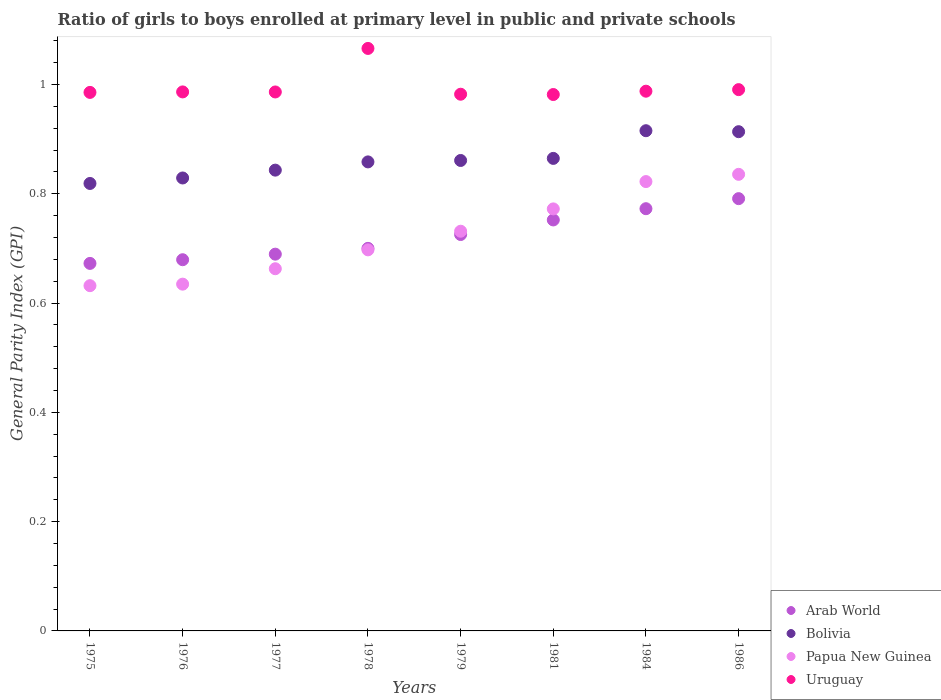What is the general parity index in Uruguay in 1979?
Offer a terse response. 0.98. Across all years, what is the maximum general parity index in Uruguay?
Make the answer very short. 1.07. Across all years, what is the minimum general parity index in Bolivia?
Give a very brief answer. 0.82. In which year was the general parity index in Uruguay minimum?
Make the answer very short. 1981. What is the total general parity index in Papua New Guinea in the graph?
Provide a succinct answer. 5.79. What is the difference between the general parity index in Papua New Guinea in 1981 and that in 1984?
Offer a very short reply. -0.05. What is the difference between the general parity index in Bolivia in 1979 and the general parity index in Uruguay in 1981?
Offer a very short reply. -0.12. What is the average general parity index in Uruguay per year?
Provide a short and direct response. 1. In the year 1981, what is the difference between the general parity index in Papua New Guinea and general parity index in Arab World?
Offer a very short reply. 0.02. In how many years, is the general parity index in Arab World greater than 0.28?
Your answer should be very brief. 8. What is the ratio of the general parity index in Papua New Guinea in 1976 to that in 1981?
Keep it short and to the point. 0.82. Is the difference between the general parity index in Papua New Guinea in 1981 and 1984 greater than the difference between the general parity index in Arab World in 1981 and 1984?
Make the answer very short. No. What is the difference between the highest and the second highest general parity index in Bolivia?
Offer a very short reply. 0. What is the difference between the highest and the lowest general parity index in Papua New Guinea?
Provide a short and direct response. 0.2. Is the sum of the general parity index in Arab World in 1977 and 1984 greater than the maximum general parity index in Uruguay across all years?
Provide a succinct answer. Yes. Is it the case that in every year, the sum of the general parity index in Papua New Guinea and general parity index in Arab World  is greater than the sum of general parity index in Bolivia and general parity index in Uruguay?
Offer a terse response. No. Is it the case that in every year, the sum of the general parity index in Papua New Guinea and general parity index in Arab World  is greater than the general parity index in Bolivia?
Provide a succinct answer. Yes. Does the general parity index in Uruguay monotonically increase over the years?
Offer a very short reply. No. Is the general parity index in Bolivia strictly greater than the general parity index in Papua New Guinea over the years?
Your answer should be very brief. Yes. Is the general parity index in Uruguay strictly less than the general parity index in Bolivia over the years?
Give a very brief answer. No. Are the values on the major ticks of Y-axis written in scientific E-notation?
Offer a terse response. No. Does the graph contain any zero values?
Your answer should be compact. No. Where does the legend appear in the graph?
Your response must be concise. Bottom right. How many legend labels are there?
Provide a short and direct response. 4. How are the legend labels stacked?
Your answer should be very brief. Vertical. What is the title of the graph?
Offer a terse response. Ratio of girls to boys enrolled at primary level in public and private schools. Does "High income: OECD" appear as one of the legend labels in the graph?
Your answer should be very brief. No. What is the label or title of the X-axis?
Your answer should be very brief. Years. What is the label or title of the Y-axis?
Ensure brevity in your answer.  General Parity Index (GPI). What is the General Parity Index (GPI) of Arab World in 1975?
Your answer should be compact. 0.67. What is the General Parity Index (GPI) in Bolivia in 1975?
Ensure brevity in your answer.  0.82. What is the General Parity Index (GPI) of Papua New Guinea in 1975?
Your answer should be very brief. 0.63. What is the General Parity Index (GPI) of Uruguay in 1975?
Keep it short and to the point. 0.99. What is the General Parity Index (GPI) of Arab World in 1976?
Ensure brevity in your answer.  0.68. What is the General Parity Index (GPI) of Bolivia in 1976?
Provide a succinct answer. 0.83. What is the General Parity Index (GPI) in Papua New Guinea in 1976?
Keep it short and to the point. 0.63. What is the General Parity Index (GPI) of Uruguay in 1976?
Give a very brief answer. 0.99. What is the General Parity Index (GPI) in Arab World in 1977?
Give a very brief answer. 0.69. What is the General Parity Index (GPI) in Bolivia in 1977?
Keep it short and to the point. 0.84. What is the General Parity Index (GPI) in Papua New Guinea in 1977?
Offer a very short reply. 0.66. What is the General Parity Index (GPI) in Uruguay in 1977?
Provide a short and direct response. 0.99. What is the General Parity Index (GPI) in Arab World in 1978?
Your answer should be compact. 0.7. What is the General Parity Index (GPI) in Bolivia in 1978?
Your answer should be compact. 0.86. What is the General Parity Index (GPI) of Papua New Guinea in 1978?
Make the answer very short. 0.7. What is the General Parity Index (GPI) of Uruguay in 1978?
Your response must be concise. 1.07. What is the General Parity Index (GPI) in Arab World in 1979?
Your answer should be compact. 0.73. What is the General Parity Index (GPI) in Bolivia in 1979?
Give a very brief answer. 0.86. What is the General Parity Index (GPI) in Papua New Guinea in 1979?
Keep it short and to the point. 0.73. What is the General Parity Index (GPI) in Uruguay in 1979?
Make the answer very short. 0.98. What is the General Parity Index (GPI) of Arab World in 1981?
Provide a short and direct response. 0.75. What is the General Parity Index (GPI) in Bolivia in 1981?
Ensure brevity in your answer.  0.86. What is the General Parity Index (GPI) in Papua New Guinea in 1981?
Your answer should be very brief. 0.77. What is the General Parity Index (GPI) of Uruguay in 1981?
Make the answer very short. 0.98. What is the General Parity Index (GPI) of Arab World in 1984?
Make the answer very short. 0.77. What is the General Parity Index (GPI) of Bolivia in 1984?
Provide a succinct answer. 0.92. What is the General Parity Index (GPI) of Papua New Guinea in 1984?
Make the answer very short. 0.82. What is the General Parity Index (GPI) in Uruguay in 1984?
Your answer should be very brief. 0.99. What is the General Parity Index (GPI) of Arab World in 1986?
Keep it short and to the point. 0.79. What is the General Parity Index (GPI) in Bolivia in 1986?
Make the answer very short. 0.91. What is the General Parity Index (GPI) of Papua New Guinea in 1986?
Make the answer very short. 0.84. What is the General Parity Index (GPI) in Uruguay in 1986?
Make the answer very short. 0.99. Across all years, what is the maximum General Parity Index (GPI) in Arab World?
Ensure brevity in your answer.  0.79. Across all years, what is the maximum General Parity Index (GPI) of Bolivia?
Your response must be concise. 0.92. Across all years, what is the maximum General Parity Index (GPI) of Papua New Guinea?
Provide a short and direct response. 0.84. Across all years, what is the maximum General Parity Index (GPI) of Uruguay?
Offer a terse response. 1.07. Across all years, what is the minimum General Parity Index (GPI) in Arab World?
Keep it short and to the point. 0.67. Across all years, what is the minimum General Parity Index (GPI) in Bolivia?
Provide a succinct answer. 0.82. Across all years, what is the minimum General Parity Index (GPI) of Papua New Guinea?
Make the answer very short. 0.63. Across all years, what is the minimum General Parity Index (GPI) in Uruguay?
Your answer should be very brief. 0.98. What is the total General Parity Index (GPI) in Arab World in the graph?
Make the answer very short. 5.78. What is the total General Parity Index (GPI) in Bolivia in the graph?
Your answer should be very brief. 6.9. What is the total General Parity Index (GPI) of Papua New Guinea in the graph?
Provide a short and direct response. 5.79. What is the total General Parity Index (GPI) in Uruguay in the graph?
Provide a short and direct response. 7.97. What is the difference between the General Parity Index (GPI) of Arab World in 1975 and that in 1976?
Your answer should be compact. -0.01. What is the difference between the General Parity Index (GPI) in Bolivia in 1975 and that in 1976?
Ensure brevity in your answer.  -0.01. What is the difference between the General Parity Index (GPI) in Papua New Guinea in 1975 and that in 1976?
Provide a short and direct response. -0. What is the difference between the General Parity Index (GPI) of Uruguay in 1975 and that in 1976?
Keep it short and to the point. -0. What is the difference between the General Parity Index (GPI) of Arab World in 1975 and that in 1977?
Provide a succinct answer. -0.02. What is the difference between the General Parity Index (GPI) in Bolivia in 1975 and that in 1977?
Your answer should be very brief. -0.02. What is the difference between the General Parity Index (GPI) of Papua New Guinea in 1975 and that in 1977?
Your answer should be very brief. -0.03. What is the difference between the General Parity Index (GPI) in Uruguay in 1975 and that in 1977?
Ensure brevity in your answer.  -0. What is the difference between the General Parity Index (GPI) in Arab World in 1975 and that in 1978?
Give a very brief answer. -0.03. What is the difference between the General Parity Index (GPI) of Bolivia in 1975 and that in 1978?
Your response must be concise. -0.04. What is the difference between the General Parity Index (GPI) in Papua New Guinea in 1975 and that in 1978?
Offer a terse response. -0.07. What is the difference between the General Parity Index (GPI) in Uruguay in 1975 and that in 1978?
Give a very brief answer. -0.08. What is the difference between the General Parity Index (GPI) in Arab World in 1975 and that in 1979?
Offer a terse response. -0.05. What is the difference between the General Parity Index (GPI) in Bolivia in 1975 and that in 1979?
Your response must be concise. -0.04. What is the difference between the General Parity Index (GPI) in Papua New Guinea in 1975 and that in 1979?
Provide a short and direct response. -0.1. What is the difference between the General Parity Index (GPI) in Uruguay in 1975 and that in 1979?
Give a very brief answer. 0. What is the difference between the General Parity Index (GPI) of Arab World in 1975 and that in 1981?
Your response must be concise. -0.08. What is the difference between the General Parity Index (GPI) of Bolivia in 1975 and that in 1981?
Your answer should be compact. -0.05. What is the difference between the General Parity Index (GPI) in Papua New Guinea in 1975 and that in 1981?
Give a very brief answer. -0.14. What is the difference between the General Parity Index (GPI) in Uruguay in 1975 and that in 1981?
Your answer should be compact. 0. What is the difference between the General Parity Index (GPI) of Arab World in 1975 and that in 1984?
Offer a terse response. -0.1. What is the difference between the General Parity Index (GPI) of Bolivia in 1975 and that in 1984?
Ensure brevity in your answer.  -0.1. What is the difference between the General Parity Index (GPI) of Papua New Guinea in 1975 and that in 1984?
Provide a short and direct response. -0.19. What is the difference between the General Parity Index (GPI) in Uruguay in 1975 and that in 1984?
Your answer should be very brief. -0. What is the difference between the General Parity Index (GPI) in Arab World in 1975 and that in 1986?
Your response must be concise. -0.12. What is the difference between the General Parity Index (GPI) in Bolivia in 1975 and that in 1986?
Provide a succinct answer. -0.09. What is the difference between the General Parity Index (GPI) of Papua New Guinea in 1975 and that in 1986?
Keep it short and to the point. -0.2. What is the difference between the General Parity Index (GPI) in Uruguay in 1975 and that in 1986?
Provide a short and direct response. -0.01. What is the difference between the General Parity Index (GPI) of Arab World in 1976 and that in 1977?
Offer a very short reply. -0.01. What is the difference between the General Parity Index (GPI) of Bolivia in 1976 and that in 1977?
Provide a succinct answer. -0.01. What is the difference between the General Parity Index (GPI) in Papua New Guinea in 1976 and that in 1977?
Make the answer very short. -0.03. What is the difference between the General Parity Index (GPI) in Arab World in 1976 and that in 1978?
Provide a succinct answer. -0.02. What is the difference between the General Parity Index (GPI) of Bolivia in 1976 and that in 1978?
Make the answer very short. -0.03. What is the difference between the General Parity Index (GPI) of Papua New Guinea in 1976 and that in 1978?
Your answer should be compact. -0.06. What is the difference between the General Parity Index (GPI) of Uruguay in 1976 and that in 1978?
Ensure brevity in your answer.  -0.08. What is the difference between the General Parity Index (GPI) of Arab World in 1976 and that in 1979?
Provide a succinct answer. -0.05. What is the difference between the General Parity Index (GPI) in Bolivia in 1976 and that in 1979?
Provide a short and direct response. -0.03. What is the difference between the General Parity Index (GPI) in Papua New Guinea in 1976 and that in 1979?
Your answer should be compact. -0.1. What is the difference between the General Parity Index (GPI) in Uruguay in 1976 and that in 1979?
Your answer should be very brief. 0. What is the difference between the General Parity Index (GPI) in Arab World in 1976 and that in 1981?
Provide a short and direct response. -0.07. What is the difference between the General Parity Index (GPI) in Bolivia in 1976 and that in 1981?
Make the answer very short. -0.04. What is the difference between the General Parity Index (GPI) of Papua New Guinea in 1976 and that in 1981?
Give a very brief answer. -0.14. What is the difference between the General Parity Index (GPI) of Uruguay in 1976 and that in 1981?
Make the answer very short. 0. What is the difference between the General Parity Index (GPI) of Arab World in 1976 and that in 1984?
Ensure brevity in your answer.  -0.09. What is the difference between the General Parity Index (GPI) of Bolivia in 1976 and that in 1984?
Ensure brevity in your answer.  -0.09. What is the difference between the General Parity Index (GPI) in Papua New Guinea in 1976 and that in 1984?
Make the answer very short. -0.19. What is the difference between the General Parity Index (GPI) of Uruguay in 1976 and that in 1984?
Provide a succinct answer. -0. What is the difference between the General Parity Index (GPI) in Arab World in 1976 and that in 1986?
Provide a short and direct response. -0.11. What is the difference between the General Parity Index (GPI) in Bolivia in 1976 and that in 1986?
Provide a short and direct response. -0.08. What is the difference between the General Parity Index (GPI) in Papua New Guinea in 1976 and that in 1986?
Ensure brevity in your answer.  -0.2. What is the difference between the General Parity Index (GPI) of Uruguay in 1976 and that in 1986?
Provide a short and direct response. -0. What is the difference between the General Parity Index (GPI) of Arab World in 1977 and that in 1978?
Your answer should be very brief. -0.01. What is the difference between the General Parity Index (GPI) of Bolivia in 1977 and that in 1978?
Make the answer very short. -0.02. What is the difference between the General Parity Index (GPI) of Papua New Guinea in 1977 and that in 1978?
Offer a very short reply. -0.03. What is the difference between the General Parity Index (GPI) of Uruguay in 1977 and that in 1978?
Your response must be concise. -0.08. What is the difference between the General Parity Index (GPI) of Arab World in 1977 and that in 1979?
Your response must be concise. -0.04. What is the difference between the General Parity Index (GPI) in Bolivia in 1977 and that in 1979?
Ensure brevity in your answer.  -0.02. What is the difference between the General Parity Index (GPI) of Papua New Guinea in 1977 and that in 1979?
Offer a terse response. -0.07. What is the difference between the General Parity Index (GPI) of Uruguay in 1977 and that in 1979?
Provide a succinct answer. 0. What is the difference between the General Parity Index (GPI) of Arab World in 1977 and that in 1981?
Ensure brevity in your answer.  -0.06. What is the difference between the General Parity Index (GPI) of Bolivia in 1977 and that in 1981?
Make the answer very short. -0.02. What is the difference between the General Parity Index (GPI) of Papua New Guinea in 1977 and that in 1981?
Make the answer very short. -0.11. What is the difference between the General Parity Index (GPI) of Uruguay in 1977 and that in 1981?
Give a very brief answer. 0. What is the difference between the General Parity Index (GPI) in Arab World in 1977 and that in 1984?
Ensure brevity in your answer.  -0.08. What is the difference between the General Parity Index (GPI) in Bolivia in 1977 and that in 1984?
Give a very brief answer. -0.07. What is the difference between the General Parity Index (GPI) of Papua New Guinea in 1977 and that in 1984?
Your answer should be very brief. -0.16. What is the difference between the General Parity Index (GPI) of Uruguay in 1977 and that in 1984?
Provide a succinct answer. -0. What is the difference between the General Parity Index (GPI) in Arab World in 1977 and that in 1986?
Keep it short and to the point. -0.1. What is the difference between the General Parity Index (GPI) of Bolivia in 1977 and that in 1986?
Your response must be concise. -0.07. What is the difference between the General Parity Index (GPI) of Papua New Guinea in 1977 and that in 1986?
Provide a succinct answer. -0.17. What is the difference between the General Parity Index (GPI) in Uruguay in 1977 and that in 1986?
Make the answer very short. -0. What is the difference between the General Parity Index (GPI) in Arab World in 1978 and that in 1979?
Your response must be concise. -0.03. What is the difference between the General Parity Index (GPI) in Bolivia in 1978 and that in 1979?
Keep it short and to the point. -0. What is the difference between the General Parity Index (GPI) of Papua New Guinea in 1978 and that in 1979?
Your response must be concise. -0.03. What is the difference between the General Parity Index (GPI) in Uruguay in 1978 and that in 1979?
Your answer should be very brief. 0.08. What is the difference between the General Parity Index (GPI) in Arab World in 1978 and that in 1981?
Offer a very short reply. -0.05. What is the difference between the General Parity Index (GPI) in Bolivia in 1978 and that in 1981?
Offer a terse response. -0.01. What is the difference between the General Parity Index (GPI) of Papua New Guinea in 1978 and that in 1981?
Offer a very short reply. -0.07. What is the difference between the General Parity Index (GPI) of Uruguay in 1978 and that in 1981?
Your answer should be compact. 0.08. What is the difference between the General Parity Index (GPI) in Arab World in 1978 and that in 1984?
Ensure brevity in your answer.  -0.07. What is the difference between the General Parity Index (GPI) of Bolivia in 1978 and that in 1984?
Make the answer very short. -0.06. What is the difference between the General Parity Index (GPI) of Papua New Guinea in 1978 and that in 1984?
Your answer should be very brief. -0.12. What is the difference between the General Parity Index (GPI) of Uruguay in 1978 and that in 1984?
Ensure brevity in your answer.  0.08. What is the difference between the General Parity Index (GPI) in Arab World in 1978 and that in 1986?
Offer a terse response. -0.09. What is the difference between the General Parity Index (GPI) in Bolivia in 1978 and that in 1986?
Ensure brevity in your answer.  -0.06. What is the difference between the General Parity Index (GPI) in Papua New Guinea in 1978 and that in 1986?
Make the answer very short. -0.14. What is the difference between the General Parity Index (GPI) in Uruguay in 1978 and that in 1986?
Offer a terse response. 0.08. What is the difference between the General Parity Index (GPI) in Arab World in 1979 and that in 1981?
Your answer should be compact. -0.03. What is the difference between the General Parity Index (GPI) of Bolivia in 1979 and that in 1981?
Your response must be concise. -0. What is the difference between the General Parity Index (GPI) of Papua New Guinea in 1979 and that in 1981?
Your answer should be compact. -0.04. What is the difference between the General Parity Index (GPI) of Uruguay in 1979 and that in 1981?
Offer a very short reply. 0. What is the difference between the General Parity Index (GPI) of Arab World in 1979 and that in 1984?
Your answer should be compact. -0.05. What is the difference between the General Parity Index (GPI) of Bolivia in 1979 and that in 1984?
Your response must be concise. -0.05. What is the difference between the General Parity Index (GPI) of Papua New Guinea in 1979 and that in 1984?
Keep it short and to the point. -0.09. What is the difference between the General Parity Index (GPI) in Uruguay in 1979 and that in 1984?
Keep it short and to the point. -0.01. What is the difference between the General Parity Index (GPI) in Arab World in 1979 and that in 1986?
Your answer should be very brief. -0.07. What is the difference between the General Parity Index (GPI) of Bolivia in 1979 and that in 1986?
Give a very brief answer. -0.05. What is the difference between the General Parity Index (GPI) in Papua New Guinea in 1979 and that in 1986?
Offer a very short reply. -0.1. What is the difference between the General Parity Index (GPI) of Uruguay in 1979 and that in 1986?
Your answer should be compact. -0.01. What is the difference between the General Parity Index (GPI) of Arab World in 1981 and that in 1984?
Offer a terse response. -0.02. What is the difference between the General Parity Index (GPI) in Bolivia in 1981 and that in 1984?
Your response must be concise. -0.05. What is the difference between the General Parity Index (GPI) of Papua New Guinea in 1981 and that in 1984?
Ensure brevity in your answer.  -0.05. What is the difference between the General Parity Index (GPI) in Uruguay in 1981 and that in 1984?
Offer a very short reply. -0.01. What is the difference between the General Parity Index (GPI) in Arab World in 1981 and that in 1986?
Offer a terse response. -0.04. What is the difference between the General Parity Index (GPI) of Bolivia in 1981 and that in 1986?
Your response must be concise. -0.05. What is the difference between the General Parity Index (GPI) of Papua New Guinea in 1981 and that in 1986?
Your answer should be very brief. -0.06. What is the difference between the General Parity Index (GPI) of Uruguay in 1981 and that in 1986?
Keep it short and to the point. -0.01. What is the difference between the General Parity Index (GPI) in Arab World in 1984 and that in 1986?
Your answer should be very brief. -0.02. What is the difference between the General Parity Index (GPI) in Bolivia in 1984 and that in 1986?
Keep it short and to the point. 0. What is the difference between the General Parity Index (GPI) of Papua New Guinea in 1984 and that in 1986?
Give a very brief answer. -0.01. What is the difference between the General Parity Index (GPI) of Uruguay in 1984 and that in 1986?
Provide a succinct answer. -0. What is the difference between the General Parity Index (GPI) in Arab World in 1975 and the General Parity Index (GPI) in Bolivia in 1976?
Your response must be concise. -0.16. What is the difference between the General Parity Index (GPI) of Arab World in 1975 and the General Parity Index (GPI) of Papua New Guinea in 1976?
Give a very brief answer. 0.04. What is the difference between the General Parity Index (GPI) of Arab World in 1975 and the General Parity Index (GPI) of Uruguay in 1976?
Ensure brevity in your answer.  -0.31. What is the difference between the General Parity Index (GPI) of Bolivia in 1975 and the General Parity Index (GPI) of Papua New Guinea in 1976?
Provide a succinct answer. 0.18. What is the difference between the General Parity Index (GPI) in Bolivia in 1975 and the General Parity Index (GPI) in Uruguay in 1976?
Provide a succinct answer. -0.17. What is the difference between the General Parity Index (GPI) of Papua New Guinea in 1975 and the General Parity Index (GPI) of Uruguay in 1976?
Make the answer very short. -0.35. What is the difference between the General Parity Index (GPI) of Arab World in 1975 and the General Parity Index (GPI) of Bolivia in 1977?
Your answer should be very brief. -0.17. What is the difference between the General Parity Index (GPI) in Arab World in 1975 and the General Parity Index (GPI) in Papua New Guinea in 1977?
Provide a short and direct response. 0.01. What is the difference between the General Parity Index (GPI) in Arab World in 1975 and the General Parity Index (GPI) in Uruguay in 1977?
Make the answer very short. -0.31. What is the difference between the General Parity Index (GPI) in Bolivia in 1975 and the General Parity Index (GPI) in Papua New Guinea in 1977?
Keep it short and to the point. 0.16. What is the difference between the General Parity Index (GPI) in Bolivia in 1975 and the General Parity Index (GPI) in Uruguay in 1977?
Offer a terse response. -0.17. What is the difference between the General Parity Index (GPI) in Papua New Guinea in 1975 and the General Parity Index (GPI) in Uruguay in 1977?
Offer a very short reply. -0.35. What is the difference between the General Parity Index (GPI) of Arab World in 1975 and the General Parity Index (GPI) of Bolivia in 1978?
Offer a very short reply. -0.19. What is the difference between the General Parity Index (GPI) of Arab World in 1975 and the General Parity Index (GPI) of Papua New Guinea in 1978?
Your response must be concise. -0.02. What is the difference between the General Parity Index (GPI) of Arab World in 1975 and the General Parity Index (GPI) of Uruguay in 1978?
Ensure brevity in your answer.  -0.39. What is the difference between the General Parity Index (GPI) of Bolivia in 1975 and the General Parity Index (GPI) of Papua New Guinea in 1978?
Offer a terse response. 0.12. What is the difference between the General Parity Index (GPI) of Bolivia in 1975 and the General Parity Index (GPI) of Uruguay in 1978?
Provide a short and direct response. -0.25. What is the difference between the General Parity Index (GPI) in Papua New Guinea in 1975 and the General Parity Index (GPI) in Uruguay in 1978?
Make the answer very short. -0.43. What is the difference between the General Parity Index (GPI) of Arab World in 1975 and the General Parity Index (GPI) of Bolivia in 1979?
Ensure brevity in your answer.  -0.19. What is the difference between the General Parity Index (GPI) in Arab World in 1975 and the General Parity Index (GPI) in Papua New Guinea in 1979?
Your answer should be compact. -0.06. What is the difference between the General Parity Index (GPI) of Arab World in 1975 and the General Parity Index (GPI) of Uruguay in 1979?
Offer a terse response. -0.31. What is the difference between the General Parity Index (GPI) in Bolivia in 1975 and the General Parity Index (GPI) in Papua New Guinea in 1979?
Provide a short and direct response. 0.09. What is the difference between the General Parity Index (GPI) in Bolivia in 1975 and the General Parity Index (GPI) in Uruguay in 1979?
Ensure brevity in your answer.  -0.16. What is the difference between the General Parity Index (GPI) in Papua New Guinea in 1975 and the General Parity Index (GPI) in Uruguay in 1979?
Ensure brevity in your answer.  -0.35. What is the difference between the General Parity Index (GPI) of Arab World in 1975 and the General Parity Index (GPI) of Bolivia in 1981?
Your response must be concise. -0.19. What is the difference between the General Parity Index (GPI) of Arab World in 1975 and the General Parity Index (GPI) of Papua New Guinea in 1981?
Offer a terse response. -0.1. What is the difference between the General Parity Index (GPI) of Arab World in 1975 and the General Parity Index (GPI) of Uruguay in 1981?
Your response must be concise. -0.31. What is the difference between the General Parity Index (GPI) of Bolivia in 1975 and the General Parity Index (GPI) of Papua New Guinea in 1981?
Your answer should be very brief. 0.05. What is the difference between the General Parity Index (GPI) of Bolivia in 1975 and the General Parity Index (GPI) of Uruguay in 1981?
Your answer should be very brief. -0.16. What is the difference between the General Parity Index (GPI) in Papua New Guinea in 1975 and the General Parity Index (GPI) in Uruguay in 1981?
Your answer should be compact. -0.35. What is the difference between the General Parity Index (GPI) of Arab World in 1975 and the General Parity Index (GPI) of Bolivia in 1984?
Offer a terse response. -0.24. What is the difference between the General Parity Index (GPI) in Arab World in 1975 and the General Parity Index (GPI) in Papua New Guinea in 1984?
Ensure brevity in your answer.  -0.15. What is the difference between the General Parity Index (GPI) of Arab World in 1975 and the General Parity Index (GPI) of Uruguay in 1984?
Your answer should be very brief. -0.32. What is the difference between the General Parity Index (GPI) of Bolivia in 1975 and the General Parity Index (GPI) of Papua New Guinea in 1984?
Your answer should be compact. -0. What is the difference between the General Parity Index (GPI) in Bolivia in 1975 and the General Parity Index (GPI) in Uruguay in 1984?
Provide a succinct answer. -0.17. What is the difference between the General Parity Index (GPI) in Papua New Guinea in 1975 and the General Parity Index (GPI) in Uruguay in 1984?
Your answer should be very brief. -0.36. What is the difference between the General Parity Index (GPI) of Arab World in 1975 and the General Parity Index (GPI) of Bolivia in 1986?
Keep it short and to the point. -0.24. What is the difference between the General Parity Index (GPI) of Arab World in 1975 and the General Parity Index (GPI) of Papua New Guinea in 1986?
Make the answer very short. -0.16. What is the difference between the General Parity Index (GPI) in Arab World in 1975 and the General Parity Index (GPI) in Uruguay in 1986?
Ensure brevity in your answer.  -0.32. What is the difference between the General Parity Index (GPI) in Bolivia in 1975 and the General Parity Index (GPI) in Papua New Guinea in 1986?
Offer a very short reply. -0.02. What is the difference between the General Parity Index (GPI) of Bolivia in 1975 and the General Parity Index (GPI) of Uruguay in 1986?
Provide a short and direct response. -0.17. What is the difference between the General Parity Index (GPI) of Papua New Guinea in 1975 and the General Parity Index (GPI) of Uruguay in 1986?
Make the answer very short. -0.36. What is the difference between the General Parity Index (GPI) of Arab World in 1976 and the General Parity Index (GPI) of Bolivia in 1977?
Your response must be concise. -0.16. What is the difference between the General Parity Index (GPI) of Arab World in 1976 and the General Parity Index (GPI) of Papua New Guinea in 1977?
Provide a short and direct response. 0.02. What is the difference between the General Parity Index (GPI) of Arab World in 1976 and the General Parity Index (GPI) of Uruguay in 1977?
Your answer should be very brief. -0.31. What is the difference between the General Parity Index (GPI) of Bolivia in 1976 and the General Parity Index (GPI) of Papua New Guinea in 1977?
Make the answer very short. 0.17. What is the difference between the General Parity Index (GPI) in Bolivia in 1976 and the General Parity Index (GPI) in Uruguay in 1977?
Keep it short and to the point. -0.16. What is the difference between the General Parity Index (GPI) in Papua New Guinea in 1976 and the General Parity Index (GPI) in Uruguay in 1977?
Offer a terse response. -0.35. What is the difference between the General Parity Index (GPI) of Arab World in 1976 and the General Parity Index (GPI) of Bolivia in 1978?
Ensure brevity in your answer.  -0.18. What is the difference between the General Parity Index (GPI) in Arab World in 1976 and the General Parity Index (GPI) in Papua New Guinea in 1978?
Ensure brevity in your answer.  -0.02. What is the difference between the General Parity Index (GPI) in Arab World in 1976 and the General Parity Index (GPI) in Uruguay in 1978?
Give a very brief answer. -0.39. What is the difference between the General Parity Index (GPI) of Bolivia in 1976 and the General Parity Index (GPI) of Papua New Guinea in 1978?
Your answer should be very brief. 0.13. What is the difference between the General Parity Index (GPI) of Bolivia in 1976 and the General Parity Index (GPI) of Uruguay in 1978?
Keep it short and to the point. -0.24. What is the difference between the General Parity Index (GPI) of Papua New Guinea in 1976 and the General Parity Index (GPI) of Uruguay in 1978?
Keep it short and to the point. -0.43. What is the difference between the General Parity Index (GPI) in Arab World in 1976 and the General Parity Index (GPI) in Bolivia in 1979?
Offer a terse response. -0.18. What is the difference between the General Parity Index (GPI) in Arab World in 1976 and the General Parity Index (GPI) in Papua New Guinea in 1979?
Offer a terse response. -0.05. What is the difference between the General Parity Index (GPI) of Arab World in 1976 and the General Parity Index (GPI) of Uruguay in 1979?
Provide a short and direct response. -0.3. What is the difference between the General Parity Index (GPI) in Bolivia in 1976 and the General Parity Index (GPI) in Papua New Guinea in 1979?
Keep it short and to the point. 0.1. What is the difference between the General Parity Index (GPI) in Bolivia in 1976 and the General Parity Index (GPI) in Uruguay in 1979?
Keep it short and to the point. -0.15. What is the difference between the General Parity Index (GPI) in Papua New Guinea in 1976 and the General Parity Index (GPI) in Uruguay in 1979?
Provide a succinct answer. -0.35. What is the difference between the General Parity Index (GPI) in Arab World in 1976 and the General Parity Index (GPI) in Bolivia in 1981?
Provide a succinct answer. -0.19. What is the difference between the General Parity Index (GPI) in Arab World in 1976 and the General Parity Index (GPI) in Papua New Guinea in 1981?
Ensure brevity in your answer.  -0.09. What is the difference between the General Parity Index (GPI) of Arab World in 1976 and the General Parity Index (GPI) of Uruguay in 1981?
Keep it short and to the point. -0.3. What is the difference between the General Parity Index (GPI) in Bolivia in 1976 and the General Parity Index (GPI) in Papua New Guinea in 1981?
Give a very brief answer. 0.06. What is the difference between the General Parity Index (GPI) of Bolivia in 1976 and the General Parity Index (GPI) of Uruguay in 1981?
Your answer should be compact. -0.15. What is the difference between the General Parity Index (GPI) in Papua New Guinea in 1976 and the General Parity Index (GPI) in Uruguay in 1981?
Ensure brevity in your answer.  -0.35. What is the difference between the General Parity Index (GPI) in Arab World in 1976 and the General Parity Index (GPI) in Bolivia in 1984?
Give a very brief answer. -0.24. What is the difference between the General Parity Index (GPI) in Arab World in 1976 and the General Parity Index (GPI) in Papua New Guinea in 1984?
Offer a very short reply. -0.14. What is the difference between the General Parity Index (GPI) in Arab World in 1976 and the General Parity Index (GPI) in Uruguay in 1984?
Give a very brief answer. -0.31. What is the difference between the General Parity Index (GPI) of Bolivia in 1976 and the General Parity Index (GPI) of Papua New Guinea in 1984?
Offer a terse response. 0.01. What is the difference between the General Parity Index (GPI) of Bolivia in 1976 and the General Parity Index (GPI) of Uruguay in 1984?
Keep it short and to the point. -0.16. What is the difference between the General Parity Index (GPI) of Papua New Guinea in 1976 and the General Parity Index (GPI) of Uruguay in 1984?
Provide a succinct answer. -0.35. What is the difference between the General Parity Index (GPI) of Arab World in 1976 and the General Parity Index (GPI) of Bolivia in 1986?
Give a very brief answer. -0.23. What is the difference between the General Parity Index (GPI) in Arab World in 1976 and the General Parity Index (GPI) in Papua New Guinea in 1986?
Ensure brevity in your answer.  -0.16. What is the difference between the General Parity Index (GPI) of Arab World in 1976 and the General Parity Index (GPI) of Uruguay in 1986?
Your response must be concise. -0.31. What is the difference between the General Parity Index (GPI) in Bolivia in 1976 and the General Parity Index (GPI) in Papua New Guinea in 1986?
Ensure brevity in your answer.  -0.01. What is the difference between the General Parity Index (GPI) of Bolivia in 1976 and the General Parity Index (GPI) of Uruguay in 1986?
Your answer should be compact. -0.16. What is the difference between the General Parity Index (GPI) of Papua New Guinea in 1976 and the General Parity Index (GPI) of Uruguay in 1986?
Ensure brevity in your answer.  -0.36. What is the difference between the General Parity Index (GPI) in Arab World in 1977 and the General Parity Index (GPI) in Bolivia in 1978?
Ensure brevity in your answer.  -0.17. What is the difference between the General Parity Index (GPI) in Arab World in 1977 and the General Parity Index (GPI) in Papua New Guinea in 1978?
Provide a short and direct response. -0.01. What is the difference between the General Parity Index (GPI) in Arab World in 1977 and the General Parity Index (GPI) in Uruguay in 1978?
Give a very brief answer. -0.38. What is the difference between the General Parity Index (GPI) of Bolivia in 1977 and the General Parity Index (GPI) of Papua New Guinea in 1978?
Provide a short and direct response. 0.15. What is the difference between the General Parity Index (GPI) of Bolivia in 1977 and the General Parity Index (GPI) of Uruguay in 1978?
Your answer should be very brief. -0.22. What is the difference between the General Parity Index (GPI) of Papua New Guinea in 1977 and the General Parity Index (GPI) of Uruguay in 1978?
Provide a succinct answer. -0.4. What is the difference between the General Parity Index (GPI) in Arab World in 1977 and the General Parity Index (GPI) in Bolivia in 1979?
Provide a short and direct response. -0.17. What is the difference between the General Parity Index (GPI) of Arab World in 1977 and the General Parity Index (GPI) of Papua New Guinea in 1979?
Your response must be concise. -0.04. What is the difference between the General Parity Index (GPI) in Arab World in 1977 and the General Parity Index (GPI) in Uruguay in 1979?
Provide a short and direct response. -0.29. What is the difference between the General Parity Index (GPI) of Bolivia in 1977 and the General Parity Index (GPI) of Papua New Guinea in 1979?
Offer a very short reply. 0.11. What is the difference between the General Parity Index (GPI) of Bolivia in 1977 and the General Parity Index (GPI) of Uruguay in 1979?
Provide a succinct answer. -0.14. What is the difference between the General Parity Index (GPI) in Papua New Guinea in 1977 and the General Parity Index (GPI) in Uruguay in 1979?
Your answer should be compact. -0.32. What is the difference between the General Parity Index (GPI) of Arab World in 1977 and the General Parity Index (GPI) of Bolivia in 1981?
Keep it short and to the point. -0.18. What is the difference between the General Parity Index (GPI) of Arab World in 1977 and the General Parity Index (GPI) of Papua New Guinea in 1981?
Give a very brief answer. -0.08. What is the difference between the General Parity Index (GPI) in Arab World in 1977 and the General Parity Index (GPI) in Uruguay in 1981?
Make the answer very short. -0.29. What is the difference between the General Parity Index (GPI) of Bolivia in 1977 and the General Parity Index (GPI) of Papua New Guinea in 1981?
Provide a short and direct response. 0.07. What is the difference between the General Parity Index (GPI) of Bolivia in 1977 and the General Parity Index (GPI) of Uruguay in 1981?
Provide a short and direct response. -0.14. What is the difference between the General Parity Index (GPI) of Papua New Guinea in 1977 and the General Parity Index (GPI) of Uruguay in 1981?
Provide a short and direct response. -0.32. What is the difference between the General Parity Index (GPI) in Arab World in 1977 and the General Parity Index (GPI) in Bolivia in 1984?
Give a very brief answer. -0.23. What is the difference between the General Parity Index (GPI) of Arab World in 1977 and the General Parity Index (GPI) of Papua New Guinea in 1984?
Your answer should be very brief. -0.13. What is the difference between the General Parity Index (GPI) of Arab World in 1977 and the General Parity Index (GPI) of Uruguay in 1984?
Your answer should be compact. -0.3. What is the difference between the General Parity Index (GPI) of Bolivia in 1977 and the General Parity Index (GPI) of Papua New Guinea in 1984?
Make the answer very short. 0.02. What is the difference between the General Parity Index (GPI) in Bolivia in 1977 and the General Parity Index (GPI) in Uruguay in 1984?
Your answer should be very brief. -0.14. What is the difference between the General Parity Index (GPI) of Papua New Guinea in 1977 and the General Parity Index (GPI) of Uruguay in 1984?
Give a very brief answer. -0.32. What is the difference between the General Parity Index (GPI) of Arab World in 1977 and the General Parity Index (GPI) of Bolivia in 1986?
Provide a short and direct response. -0.22. What is the difference between the General Parity Index (GPI) of Arab World in 1977 and the General Parity Index (GPI) of Papua New Guinea in 1986?
Your answer should be very brief. -0.15. What is the difference between the General Parity Index (GPI) in Arab World in 1977 and the General Parity Index (GPI) in Uruguay in 1986?
Offer a very short reply. -0.3. What is the difference between the General Parity Index (GPI) of Bolivia in 1977 and the General Parity Index (GPI) of Papua New Guinea in 1986?
Offer a terse response. 0.01. What is the difference between the General Parity Index (GPI) of Bolivia in 1977 and the General Parity Index (GPI) of Uruguay in 1986?
Your answer should be very brief. -0.15. What is the difference between the General Parity Index (GPI) of Papua New Guinea in 1977 and the General Parity Index (GPI) of Uruguay in 1986?
Keep it short and to the point. -0.33. What is the difference between the General Parity Index (GPI) in Arab World in 1978 and the General Parity Index (GPI) in Bolivia in 1979?
Make the answer very short. -0.16. What is the difference between the General Parity Index (GPI) in Arab World in 1978 and the General Parity Index (GPI) in Papua New Guinea in 1979?
Make the answer very short. -0.03. What is the difference between the General Parity Index (GPI) in Arab World in 1978 and the General Parity Index (GPI) in Uruguay in 1979?
Make the answer very short. -0.28. What is the difference between the General Parity Index (GPI) of Bolivia in 1978 and the General Parity Index (GPI) of Papua New Guinea in 1979?
Ensure brevity in your answer.  0.13. What is the difference between the General Parity Index (GPI) of Bolivia in 1978 and the General Parity Index (GPI) of Uruguay in 1979?
Make the answer very short. -0.12. What is the difference between the General Parity Index (GPI) in Papua New Guinea in 1978 and the General Parity Index (GPI) in Uruguay in 1979?
Your answer should be very brief. -0.28. What is the difference between the General Parity Index (GPI) of Arab World in 1978 and the General Parity Index (GPI) of Bolivia in 1981?
Provide a succinct answer. -0.16. What is the difference between the General Parity Index (GPI) in Arab World in 1978 and the General Parity Index (GPI) in Papua New Guinea in 1981?
Your answer should be compact. -0.07. What is the difference between the General Parity Index (GPI) of Arab World in 1978 and the General Parity Index (GPI) of Uruguay in 1981?
Ensure brevity in your answer.  -0.28. What is the difference between the General Parity Index (GPI) of Bolivia in 1978 and the General Parity Index (GPI) of Papua New Guinea in 1981?
Give a very brief answer. 0.09. What is the difference between the General Parity Index (GPI) in Bolivia in 1978 and the General Parity Index (GPI) in Uruguay in 1981?
Keep it short and to the point. -0.12. What is the difference between the General Parity Index (GPI) of Papua New Guinea in 1978 and the General Parity Index (GPI) of Uruguay in 1981?
Ensure brevity in your answer.  -0.28. What is the difference between the General Parity Index (GPI) in Arab World in 1978 and the General Parity Index (GPI) in Bolivia in 1984?
Offer a very short reply. -0.22. What is the difference between the General Parity Index (GPI) in Arab World in 1978 and the General Parity Index (GPI) in Papua New Guinea in 1984?
Provide a short and direct response. -0.12. What is the difference between the General Parity Index (GPI) of Arab World in 1978 and the General Parity Index (GPI) of Uruguay in 1984?
Keep it short and to the point. -0.29. What is the difference between the General Parity Index (GPI) in Bolivia in 1978 and the General Parity Index (GPI) in Papua New Guinea in 1984?
Make the answer very short. 0.04. What is the difference between the General Parity Index (GPI) of Bolivia in 1978 and the General Parity Index (GPI) of Uruguay in 1984?
Provide a short and direct response. -0.13. What is the difference between the General Parity Index (GPI) in Papua New Guinea in 1978 and the General Parity Index (GPI) in Uruguay in 1984?
Provide a succinct answer. -0.29. What is the difference between the General Parity Index (GPI) in Arab World in 1978 and the General Parity Index (GPI) in Bolivia in 1986?
Provide a short and direct response. -0.21. What is the difference between the General Parity Index (GPI) of Arab World in 1978 and the General Parity Index (GPI) of Papua New Guinea in 1986?
Your answer should be very brief. -0.14. What is the difference between the General Parity Index (GPI) in Arab World in 1978 and the General Parity Index (GPI) in Uruguay in 1986?
Your response must be concise. -0.29. What is the difference between the General Parity Index (GPI) in Bolivia in 1978 and the General Parity Index (GPI) in Papua New Guinea in 1986?
Provide a succinct answer. 0.02. What is the difference between the General Parity Index (GPI) in Bolivia in 1978 and the General Parity Index (GPI) in Uruguay in 1986?
Offer a terse response. -0.13. What is the difference between the General Parity Index (GPI) in Papua New Guinea in 1978 and the General Parity Index (GPI) in Uruguay in 1986?
Offer a terse response. -0.29. What is the difference between the General Parity Index (GPI) in Arab World in 1979 and the General Parity Index (GPI) in Bolivia in 1981?
Your answer should be very brief. -0.14. What is the difference between the General Parity Index (GPI) of Arab World in 1979 and the General Parity Index (GPI) of Papua New Guinea in 1981?
Ensure brevity in your answer.  -0.05. What is the difference between the General Parity Index (GPI) of Arab World in 1979 and the General Parity Index (GPI) of Uruguay in 1981?
Your answer should be compact. -0.26. What is the difference between the General Parity Index (GPI) in Bolivia in 1979 and the General Parity Index (GPI) in Papua New Guinea in 1981?
Offer a terse response. 0.09. What is the difference between the General Parity Index (GPI) in Bolivia in 1979 and the General Parity Index (GPI) in Uruguay in 1981?
Make the answer very short. -0.12. What is the difference between the General Parity Index (GPI) of Papua New Guinea in 1979 and the General Parity Index (GPI) of Uruguay in 1981?
Provide a short and direct response. -0.25. What is the difference between the General Parity Index (GPI) of Arab World in 1979 and the General Parity Index (GPI) of Bolivia in 1984?
Give a very brief answer. -0.19. What is the difference between the General Parity Index (GPI) in Arab World in 1979 and the General Parity Index (GPI) in Papua New Guinea in 1984?
Offer a terse response. -0.1. What is the difference between the General Parity Index (GPI) of Arab World in 1979 and the General Parity Index (GPI) of Uruguay in 1984?
Offer a terse response. -0.26. What is the difference between the General Parity Index (GPI) in Bolivia in 1979 and the General Parity Index (GPI) in Papua New Guinea in 1984?
Ensure brevity in your answer.  0.04. What is the difference between the General Parity Index (GPI) of Bolivia in 1979 and the General Parity Index (GPI) of Uruguay in 1984?
Provide a succinct answer. -0.13. What is the difference between the General Parity Index (GPI) of Papua New Guinea in 1979 and the General Parity Index (GPI) of Uruguay in 1984?
Offer a very short reply. -0.26. What is the difference between the General Parity Index (GPI) in Arab World in 1979 and the General Parity Index (GPI) in Bolivia in 1986?
Keep it short and to the point. -0.19. What is the difference between the General Parity Index (GPI) of Arab World in 1979 and the General Parity Index (GPI) of Papua New Guinea in 1986?
Offer a very short reply. -0.11. What is the difference between the General Parity Index (GPI) of Arab World in 1979 and the General Parity Index (GPI) of Uruguay in 1986?
Your response must be concise. -0.27. What is the difference between the General Parity Index (GPI) of Bolivia in 1979 and the General Parity Index (GPI) of Papua New Guinea in 1986?
Make the answer very short. 0.03. What is the difference between the General Parity Index (GPI) in Bolivia in 1979 and the General Parity Index (GPI) in Uruguay in 1986?
Your answer should be very brief. -0.13. What is the difference between the General Parity Index (GPI) of Papua New Guinea in 1979 and the General Parity Index (GPI) of Uruguay in 1986?
Offer a very short reply. -0.26. What is the difference between the General Parity Index (GPI) in Arab World in 1981 and the General Parity Index (GPI) in Bolivia in 1984?
Your answer should be very brief. -0.16. What is the difference between the General Parity Index (GPI) in Arab World in 1981 and the General Parity Index (GPI) in Papua New Guinea in 1984?
Provide a succinct answer. -0.07. What is the difference between the General Parity Index (GPI) of Arab World in 1981 and the General Parity Index (GPI) of Uruguay in 1984?
Offer a terse response. -0.24. What is the difference between the General Parity Index (GPI) in Bolivia in 1981 and the General Parity Index (GPI) in Papua New Guinea in 1984?
Ensure brevity in your answer.  0.04. What is the difference between the General Parity Index (GPI) of Bolivia in 1981 and the General Parity Index (GPI) of Uruguay in 1984?
Your answer should be compact. -0.12. What is the difference between the General Parity Index (GPI) in Papua New Guinea in 1981 and the General Parity Index (GPI) in Uruguay in 1984?
Your answer should be compact. -0.22. What is the difference between the General Parity Index (GPI) of Arab World in 1981 and the General Parity Index (GPI) of Bolivia in 1986?
Give a very brief answer. -0.16. What is the difference between the General Parity Index (GPI) in Arab World in 1981 and the General Parity Index (GPI) in Papua New Guinea in 1986?
Give a very brief answer. -0.08. What is the difference between the General Parity Index (GPI) of Arab World in 1981 and the General Parity Index (GPI) of Uruguay in 1986?
Your answer should be compact. -0.24. What is the difference between the General Parity Index (GPI) of Bolivia in 1981 and the General Parity Index (GPI) of Papua New Guinea in 1986?
Give a very brief answer. 0.03. What is the difference between the General Parity Index (GPI) of Bolivia in 1981 and the General Parity Index (GPI) of Uruguay in 1986?
Ensure brevity in your answer.  -0.13. What is the difference between the General Parity Index (GPI) in Papua New Guinea in 1981 and the General Parity Index (GPI) in Uruguay in 1986?
Your response must be concise. -0.22. What is the difference between the General Parity Index (GPI) of Arab World in 1984 and the General Parity Index (GPI) of Bolivia in 1986?
Your answer should be compact. -0.14. What is the difference between the General Parity Index (GPI) in Arab World in 1984 and the General Parity Index (GPI) in Papua New Guinea in 1986?
Your answer should be very brief. -0.06. What is the difference between the General Parity Index (GPI) in Arab World in 1984 and the General Parity Index (GPI) in Uruguay in 1986?
Ensure brevity in your answer.  -0.22. What is the difference between the General Parity Index (GPI) of Bolivia in 1984 and the General Parity Index (GPI) of Papua New Guinea in 1986?
Your answer should be very brief. 0.08. What is the difference between the General Parity Index (GPI) of Bolivia in 1984 and the General Parity Index (GPI) of Uruguay in 1986?
Your response must be concise. -0.08. What is the difference between the General Parity Index (GPI) of Papua New Guinea in 1984 and the General Parity Index (GPI) of Uruguay in 1986?
Ensure brevity in your answer.  -0.17. What is the average General Parity Index (GPI) of Arab World per year?
Give a very brief answer. 0.72. What is the average General Parity Index (GPI) of Bolivia per year?
Give a very brief answer. 0.86. What is the average General Parity Index (GPI) in Papua New Guinea per year?
Offer a terse response. 0.72. What is the average General Parity Index (GPI) in Uruguay per year?
Keep it short and to the point. 1. In the year 1975, what is the difference between the General Parity Index (GPI) of Arab World and General Parity Index (GPI) of Bolivia?
Give a very brief answer. -0.15. In the year 1975, what is the difference between the General Parity Index (GPI) of Arab World and General Parity Index (GPI) of Papua New Guinea?
Ensure brevity in your answer.  0.04. In the year 1975, what is the difference between the General Parity Index (GPI) in Arab World and General Parity Index (GPI) in Uruguay?
Your answer should be compact. -0.31. In the year 1975, what is the difference between the General Parity Index (GPI) of Bolivia and General Parity Index (GPI) of Papua New Guinea?
Keep it short and to the point. 0.19. In the year 1975, what is the difference between the General Parity Index (GPI) in Bolivia and General Parity Index (GPI) in Uruguay?
Make the answer very short. -0.17. In the year 1975, what is the difference between the General Parity Index (GPI) in Papua New Guinea and General Parity Index (GPI) in Uruguay?
Your answer should be very brief. -0.35. In the year 1976, what is the difference between the General Parity Index (GPI) of Arab World and General Parity Index (GPI) of Bolivia?
Make the answer very short. -0.15. In the year 1976, what is the difference between the General Parity Index (GPI) in Arab World and General Parity Index (GPI) in Papua New Guinea?
Provide a succinct answer. 0.04. In the year 1976, what is the difference between the General Parity Index (GPI) in Arab World and General Parity Index (GPI) in Uruguay?
Your answer should be very brief. -0.31. In the year 1976, what is the difference between the General Parity Index (GPI) of Bolivia and General Parity Index (GPI) of Papua New Guinea?
Your response must be concise. 0.19. In the year 1976, what is the difference between the General Parity Index (GPI) in Bolivia and General Parity Index (GPI) in Uruguay?
Your answer should be compact. -0.16. In the year 1976, what is the difference between the General Parity Index (GPI) in Papua New Guinea and General Parity Index (GPI) in Uruguay?
Offer a terse response. -0.35. In the year 1977, what is the difference between the General Parity Index (GPI) in Arab World and General Parity Index (GPI) in Bolivia?
Give a very brief answer. -0.15. In the year 1977, what is the difference between the General Parity Index (GPI) of Arab World and General Parity Index (GPI) of Papua New Guinea?
Ensure brevity in your answer.  0.03. In the year 1977, what is the difference between the General Parity Index (GPI) in Arab World and General Parity Index (GPI) in Uruguay?
Provide a short and direct response. -0.3. In the year 1977, what is the difference between the General Parity Index (GPI) in Bolivia and General Parity Index (GPI) in Papua New Guinea?
Provide a short and direct response. 0.18. In the year 1977, what is the difference between the General Parity Index (GPI) of Bolivia and General Parity Index (GPI) of Uruguay?
Your response must be concise. -0.14. In the year 1977, what is the difference between the General Parity Index (GPI) in Papua New Guinea and General Parity Index (GPI) in Uruguay?
Ensure brevity in your answer.  -0.32. In the year 1978, what is the difference between the General Parity Index (GPI) of Arab World and General Parity Index (GPI) of Bolivia?
Keep it short and to the point. -0.16. In the year 1978, what is the difference between the General Parity Index (GPI) of Arab World and General Parity Index (GPI) of Papua New Guinea?
Provide a succinct answer. 0. In the year 1978, what is the difference between the General Parity Index (GPI) in Arab World and General Parity Index (GPI) in Uruguay?
Provide a succinct answer. -0.37. In the year 1978, what is the difference between the General Parity Index (GPI) in Bolivia and General Parity Index (GPI) in Papua New Guinea?
Your answer should be compact. 0.16. In the year 1978, what is the difference between the General Parity Index (GPI) in Bolivia and General Parity Index (GPI) in Uruguay?
Your answer should be compact. -0.21. In the year 1978, what is the difference between the General Parity Index (GPI) in Papua New Guinea and General Parity Index (GPI) in Uruguay?
Offer a very short reply. -0.37. In the year 1979, what is the difference between the General Parity Index (GPI) of Arab World and General Parity Index (GPI) of Bolivia?
Make the answer very short. -0.14. In the year 1979, what is the difference between the General Parity Index (GPI) in Arab World and General Parity Index (GPI) in Papua New Guinea?
Ensure brevity in your answer.  -0.01. In the year 1979, what is the difference between the General Parity Index (GPI) of Arab World and General Parity Index (GPI) of Uruguay?
Provide a short and direct response. -0.26. In the year 1979, what is the difference between the General Parity Index (GPI) of Bolivia and General Parity Index (GPI) of Papua New Guinea?
Keep it short and to the point. 0.13. In the year 1979, what is the difference between the General Parity Index (GPI) in Bolivia and General Parity Index (GPI) in Uruguay?
Your response must be concise. -0.12. In the year 1979, what is the difference between the General Parity Index (GPI) of Papua New Guinea and General Parity Index (GPI) of Uruguay?
Make the answer very short. -0.25. In the year 1981, what is the difference between the General Parity Index (GPI) of Arab World and General Parity Index (GPI) of Bolivia?
Provide a succinct answer. -0.11. In the year 1981, what is the difference between the General Parity Index (GPI) in Arab World and General Parity Index (GPI) in Papua New Guinea?
Keep it short and to the point. -0.02. In the year 1981, what is the difference between the General Parity Index (GPI) in Arab World and General Parity Index (GPI) in Uruguay?
Make the answer very short. -0.23. In the year 1981, what is the difference between the General Parity Index (GPI) in Bolivia and General Parity Index (GPI) in Papua New Guinea?
Provide a short and direct response. 0.09. In the year 1981, what is the difference between the General Parity Index (GPI) in Bolivia and General Parity Index (GPI) in Uruguay?
Offer a very short reply. -0.12. In the year 1981, what is the difference between the General Parity Index (GPI) of Papua New Guinea and General Parity Index (GPI) of Uruguay?
Your answer should be compact. -0.21. In the year 1984, what is the difference between the General Parity Index (GPI) in Arab World and General Parity Index (GPI) in Bolivia?
Provide a succinct answer. -0.14. In the year 1984, what is the difference between the General Parity Index (GPI) in Arab World and General Parity Index (GPI) in Papua New Guinea?
Make the answer very short. -0.05. In the year 1984, what is the difference between the General Parity Index (GPI) in Arab World and General Parity Index (GPI) in Uruguay?
Keep it short and to the point. -0.21. In the year 1984, what is the difference between the General Parity Index (GPI) in Bolivia and General Parity Index (GPI) in Papua New Guinea?
Keep it short and to the point. 0.09. In the year 1984, what is the difference between the General Parity Index (GPI) in Bolivia and General Parity Index (GPI) in Uruguay?
Provide a short and direct response. -0.07. In the year 1984, what is the difference between the General Parity Index (GPI) in Papua New Guinea and General Parity Index (GPI) in Uruguay?
Your answer should be very brief. -0.17. In the year 1986, what is the difference between the General Parity Index (GPI) in Arab World and General Parity Index (GPI) in Bolivia?
Your answer should be very brief. -0.12. In the year 1986, what is the difference between the General Parity Index (GPI) of Arab World and General Parity Index (GPI) of Papua New Guinea?
Your answer should be very brief. -0.04. In the year 1986, what is the difference between the General Parity Index (GPI) of Arab World and General Parity Index (GPI) of Uruguay?
Provide a short and direct response. -0.2. In the year 1986, what is the difference between the General Parity Index (GPI) of Bolivia and General Parity Index (GPI) of Papua New Guinea?
Your response must be concise. 0.08. In the year 1986, what is the difference between the General Parity Index (GPI) in Bolivia and General Parity Index (GPI) in Uruguay?
Your response must be concise. -0.08. In the year 1986, what is the difference between the General Parity Index (GPI) of Papua New Guinea and General Parity Index (GPI) of Uruguay?
Give a very brief answer. -0.15. What is the ratio of the General Parity Index (GPI) in Bolivia in 1975 to that in 1976?
Your answer should be very brief. 0.99. What is the ratio of the General Parity Index (GPI) in Papua New Guinea in 1975 to that in 1976?
Keep it short and to the point. 1. What is the ratio of the General Parity Index (GPI) in Arab World in 1975 to that in 1977?
Your answer should be compact. 0.98. What is the ratio of the General Parity Index (GPI) in Bolivia in 1975 to that in 1977?
Offer a very short reply. 0.97. What is the ratio of the General Parity Index (GPI) in Papua New Guinea in 1975 to that in 1977?
Offer a terse response. 0.95. What is the ratio of the General Parity Index (GPI) of Uruguay in 1975 to that in 1977?
Offer a terse response. 1. What is the ratio of the General Parity Index (GPI) in Arab World in 1975 to that in 1978?
Offer a very short reply. 0.96. What is the ratio of the General Parity Index (GPI) of Bolivia in 1975 to that in 1978?
Give a very brief answer. 0.95. What is the ratio of the General Parity Index (GPI) in Papua New Guinea in 1975 to that in 1978?
Provide a succinct answer. 0.91. What is the ratio of the General Parity Index (GPI) of Uruguay in 1975 to that in 1978?
Ensure brevity in your answer.  0.92. What is the ratio of the General Parity Index (GPI) in Arab World in 1975 to that in 1979?
Offer a terse response. 0.93. What is the ratio of the General Parity Index (GPI) of Bolivia in 1975 to that in 1979?
Ensure brevity in your answer.  0.95. What is the ratio of the General Parity Index (GPI) of Papua New Guinea in 1975 to that in 1979?
Provide a succinct answer. 0.86. What is the ratio of the General Parity Index (GPI) of Arab World in 1975 to that in 1981?
Ensure brevity in your answer.  0.89. What is the ratio of the General Parity Index (GPI) in Bolivia in 1975 to that in 1981?
Offer a terse response. 0.95. What is the ratio of the General Parity Index (GPI) in Papua New Guinea in 1975 to that in 1981?
Give a very brief answer. 0.82. What is the ratio of the General Parity Index (GPI) of Uruguay in 1975 to that in 1981?
Offer a very short reply. 1. What is the ratio of the General Parity Index (GPI) of Arab World in 1975 to that in 1984?
Your answer should be compact. 0.87. What is the ratio of the General Parity Index (GPI) of Bolivia in 1975 to that in 1984?
Offer a very short reply. 0.89. What is the ratio of the General Parity Index (GPI) of Papua New Guinea in 1975 to that in 1984?
Give a very brief answer. 0.77. What is the ratio of the General Parity Index (GPI) of Uruguay in 1975 to that in 1984?
Offer a terse response. 1. What is the ratio of the General Parity Index (GPI) in Arab World in 1975 to that in 1986?
Ensure brevity in your answer.  0.85. What is the ratio of the General Parity Index (GPI) in Bolivia in 1975 to that in 1986?
Offer a terse response. 0.9. What is the ratio of the General Parity Index (GPI) of Papua New Guinea in 1975 to that in 1986?
Keep it short and to the point. 0.76. What is the ratio of the General Parity Index (GPI) of Uruguay in 1975 to that in 1986?
Keep it short and to the point. 0.99. What is the ratio of the General Parity Index (GPI) in Arab World in 1976 to that in 1977?
Make the answer very short. 0.99. What is the ratio of the General Parity Index (GPI) of Bolivia in 1976 to that in 1977?
Provide a succinct answer. 0.98. What is the ratio of the General Parity Index (GPI) in Papua New Guinea in 1976 to that in 1977?
Provide a short and direct response. 0.96. What is the ratio of the General Parity Index (GPI) of Arab World in 1976 to that in 1978?
Offer a terse response. 0.97. What is the ratio of the General Parity Index (GPI) of Bolivia in 1976 to that in 1978?
Keep it short and to the point. 0.97. What is the ratio of the General Parity Index (GPI) in Papua New Guinea in 1976 to that in 1978?
Give a very brief answer. 0.91. What is the ratio of the General Parity Index (GPI) in Uruguay in 1976 to that in 1978?
Offer a terse response. 0.93. What is the ratio of the General Parity Index (GPI) in Arab World in 1976 to that in 1979?
Provide a short and direct response. 0.94. What is the ratio of the General Parity Index (GPI) in Bolivia in 1976 to that in 1979?
Your answer should be very brief. 0.96. What is the ratio of the General Parity Index (GPI) of Papua New Guinea in 1976 to that in 1979?
Your response must be concise. 0.87. What is the ratio of the General Parity Index (GPI) in Arab World in 1976 to that in 1981?
Offer a terse response. 0.9. What is the ratio of the General Parity Index (GPI) of Bolivia in 1976 to that in 1981?
Make the answer very short. 0.96. What is the ratio of the General Parity Index (GPI) of Papua New Guinea in 1976 to that in 1981?
Provide a succinct answer. 0.82. What is the ratio of the General Parity Index (GPI) in Arab World in 1976 to that in 1984?
Your answer should be compact. 0.88. What is the ratio of the General Parity Index (GPI) in Bolivia in 1976 to that in 1984?
Make the answer very short. 0.91. What is the ratio of the General Parity Index (GPI) in Papua New Guinea in 1976 to that in 1984?
Provide a succinct answer. 0.77. What is the ratio of the General Parity Index (GPI) of Uruguay in 1976 to that in 1984?
Ensure brevity in your answer.  1. What is the ratio of the General Parity Index (GPI) in Arab World in 1976 to that in 1986?
Provide a short and direct response. 0.86. What is the ratio of the General Parity Index (GPI) of Bolivia in 1976 to that in 1986?
Provide a succinct answer. 0.91. What is the ratio of the General Parity Index (GPI) in Papua New Guinea in 1976 to that in 1986?
Offer a terse response. 0.76. What is the ratio of the General Parity Index (GPI) in Bolivia in 1977 to that in 1978?
Keep it short and to the point. 0.98. What is the ratio of the General Parity Index (GPI) of Papua New Guinea in 1977 to that in 1978?
Offer a very short reply. 0.95. What is the ratio of the General Parity Index (GPI) in Uruguay in 1977 to that in 1978?
Your response must be concise. 0.93. What is the ratio of the General Parity Index (GPI) in Arab World in 1977 to that in 1979?
Ensure brevity in your answer.  0.95. What is the ratio of the General Parity Index (GPI) of Bolivia in 1977 to that in 1979?
Offer a very short reply. 0.98. What is the ratio of the General Parity Index (GPI) in Papua New Guinea in 1977 to that in 1979?
Your answer should be very brief. 0.91. What is the ratio of the General Parity Index (GPI) in Arab World in 1977 to that in 1981?
Provide a short and direct response. 0.92. What is the ratio of the General Parity Index (GPI) of Bolivia in 1977 to that in 1981?
Your response must be concise. 0.98. What is the ratio of the General Parity Index (GPI) in Papua New Guinea in 1977 to that in 1981?
Make the answer very short. 0.86. What is the ratio of the General Parity Index (GPI) of Arab World in 1977 to that in 1984?
Give a very brief answer. 0.89. What is the ratio of the General Parity Index (GPI) of Bolivia in 1977 to that in 1984?
Make the answer very short. 0.92. What is the ratio of the General Parity Index (GPI) of Papua New Guinea in 1977 to that in 1984?
Make the answer very short. 0.81. What is the ratio of the General Parity Index (GPI) in Arab World in 1977 to that in 1986?
Keep it short and to the point. 0.87. What is the ratio of the General Parity Index (GPI) in Bolivia in 1977 to that in 1986?
Offer a very short reply. 0.92. What is the ratio of the General Parity Index (GPI) of Papua New Guinea in 1977 to that in 1986?
Ensure brevity in your answer.  0.79. What is the ratio of the General Parity Index (GPI) of Arab World in 1978 to that in 1979?
Provide a short and direct response. 0.97. What is the ratio of the General Parity Index (GPI) in Bolivia in 1978 to that in 1979?
Offer a very short reply. 1. What is the ratio of the General Parity Index (GPI) of Papua New Guinea in 1978 to that in 1979?
Make the answer very short. 0.95. What is the ratio of the General Parity Index (GPI) of Uruguay in 1978 to that in 1979?
Provide a short and direct response. 1.09. What is the ratio of the General Parity Index (GPI) of Arab World in 1978 to that in 1981?
Offer a very short reply. 0.93. What is the ratio of the General Parity Index (GPI) of Papua New Guinea in 1978 to that in 1981?
Your answer should be compact. 0.9. What is the ratio of the General Parity Index (GPI) in Uruguay in 1978 to that in 1981?
Your response must be concise. 1.09. What is the ratio of the General Parity Index (GPI) in Arab World in 1978 to that in 1984?
Your response must be concise. 0.91. What is the ratio of the General Parity Index (GPI) of Bolivia in 1978 to that in 1984?
Offer a terse response. 0.94. What is the ratio of the General Parity Index (GPI) of Papua New Guinea in 1978 to that in 1984?
Provide a short and direct response. 0.85. What is the ratio of the General Parity Index (GPI) of Uruguay in 1978 to that in 1984?
Your answer should be very brief. 1.08. What is the ratio of the General Parity Index (GPI) of Arab World in 1978 to that in 1986?
Your answer should be very brief. 0.89. What is the ratio of the General Parity Index (GPI) of Bolivia in 1978 to that in 1986?
Ensure brevity in your answer.  0.94. What is the ratio of the General Parity Index (GPI) of Papua New Guinea in 1978 to that in 1986?
Your answer should be compact. 0.83. What is the ratio of the General Parity Index (GPI) in Uruguay in 1978 to that in 1986?
Provide a succinct answer. 1.08. What is the ratio of the General Parity Index (GPI) of Arab World in 1979 to that in 1981?
Offer a very short reply. 0.96. What is the ratio of the General Parity Index (GPI) of Bolivia in 1979 to that in 1981?
Provide a succinct answer. 1. What is the ratio of the General Parity Index (GPI) of Papua New Guinea in 1979 to that in 1981?
Offer a terse response. 0.95. What is the ratio of the General Parity Index (GPI) in Arab World in 1979 to that in 1984?
Offer a terse response. 0.94. What is the ratio of the General Parity Index (GPI) in Bolivia in 1979 to that in 1984?
Provide a short and direct response. 0.94. What is the ratio of the General Parity Index (GPI) of Papua New Guinea in 1979 to that in 1984?
Keep it short and to the point. 0.89. What is the ratio of the General Parity Index (GPI) of Uruguay in 1979 to that in 1984?
Give a very brief answer. 0.99. What is the ratio of the General Parity Index (GPI) of Arab World in 1979 to that in 1986?
Make the answer very short. 0.92. What is the ratio of the General Parity Index (GPI) in Bolivia in 1979 to that in 1986?
Provide a succinct answer. 0.94. What is the ratio of the General Parity Index (GPI) of Papua New Guinea in 1979 to that in 1986?
Provide a succinct answer. 0.88. What is the ratio of the General Parity Index (GPI) of Arab World in 1981 to that in 1984?
Offer a terse response. 0.97. What is the ratio of the General Parity Index (GPI) of Bolivia in 1981 to that in 1984?
Offer a terse response. 0.94. What is the ratio of the General Parity Index (GPI) of Papua New Guinea in 1981 to that in 1984?
Make the answer very short. 0.94. What is the ratio of the General Parity Index (GPI) in Uruguay in 1981 to that in 1984?
Your answer should be compact. 0.99. What is the ratio of the General Parity Index (GPI) of Arab World in 1981 to that in 1986?
Your answer should be very brief. 0.95. What is the ratio of the General Parity Index (GPI) in Bolivia in 1981 to that in 1986?
Give a very brief answer. 0.95. What is the ratio of the General Parity Index (GPI) of Papua New Guinea in 1981 to that in 1986?
Provide a succinct answer. 0.92. What is the ratio of the General Parity Index (GPI) in Uruguay in 1981 to that in 1986?
Offer a very short reply. 0.99. What is the ratio of the General Parity Index (GPI) of Arab World in 1984 to that in 1986?
Give a very brief answer. 0.98. What is the ratio of the General Parity Index (GPI) of Papua New Guinea in 1984 to that in 1986?
Your response must be concise. 0.98. What is the difference between the highest and the second highest General Parity Index (GPI) in Arab World?
Offer a very short reply. 0.02. What is the difference between the highest and the second highest General Parity Index (GPI) of Bolivia?
Offer a very short reply. 0. What is the difference between the highest and the second highest General Parity Index (GPI) in Papua New Guinea?
Your answer should be compact. 0.01. What is the difference between the highest and the second highest General Parity Index (GPI) of Uruguay?
Your response must be concise. 0.08. What is the difference between the highest and the lowest General Parity Index (GPI) of Arab World?
Your response must be concise. 0.12. What is the difference between the highest and the lowest General Parity Index (GPI) in Bolivia?
Provide a short and direct response. 0.1. What is the difference between the highest and the lowest General Parity Index (GPI) of Papua New Guinea?
Make the answer very short. 0.2. What is the difference between the highest and the lowest General Parity Index (GPI) in Uruguay?
Provide a succinct answer. 0.08. 